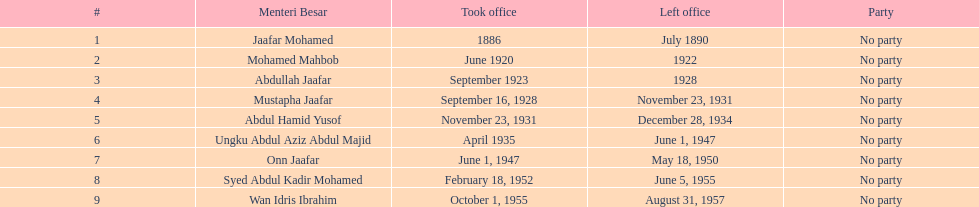After abdullah jaafar, who assumed office? Mustapha Jaafar. 